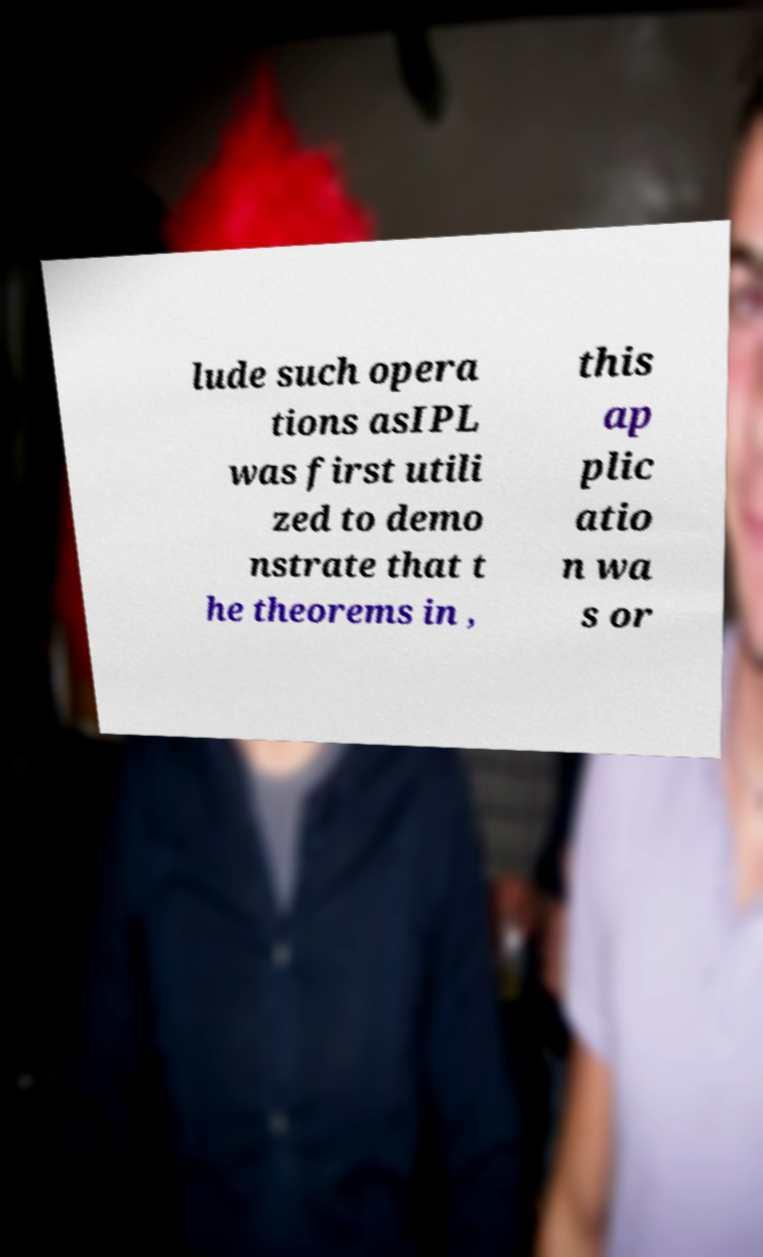Please identify and transcribe the text found in this image. lude such opera tions asIPL was first utili zed to demo nstrate that t he theorems in , this ap plic atio n wa s or 